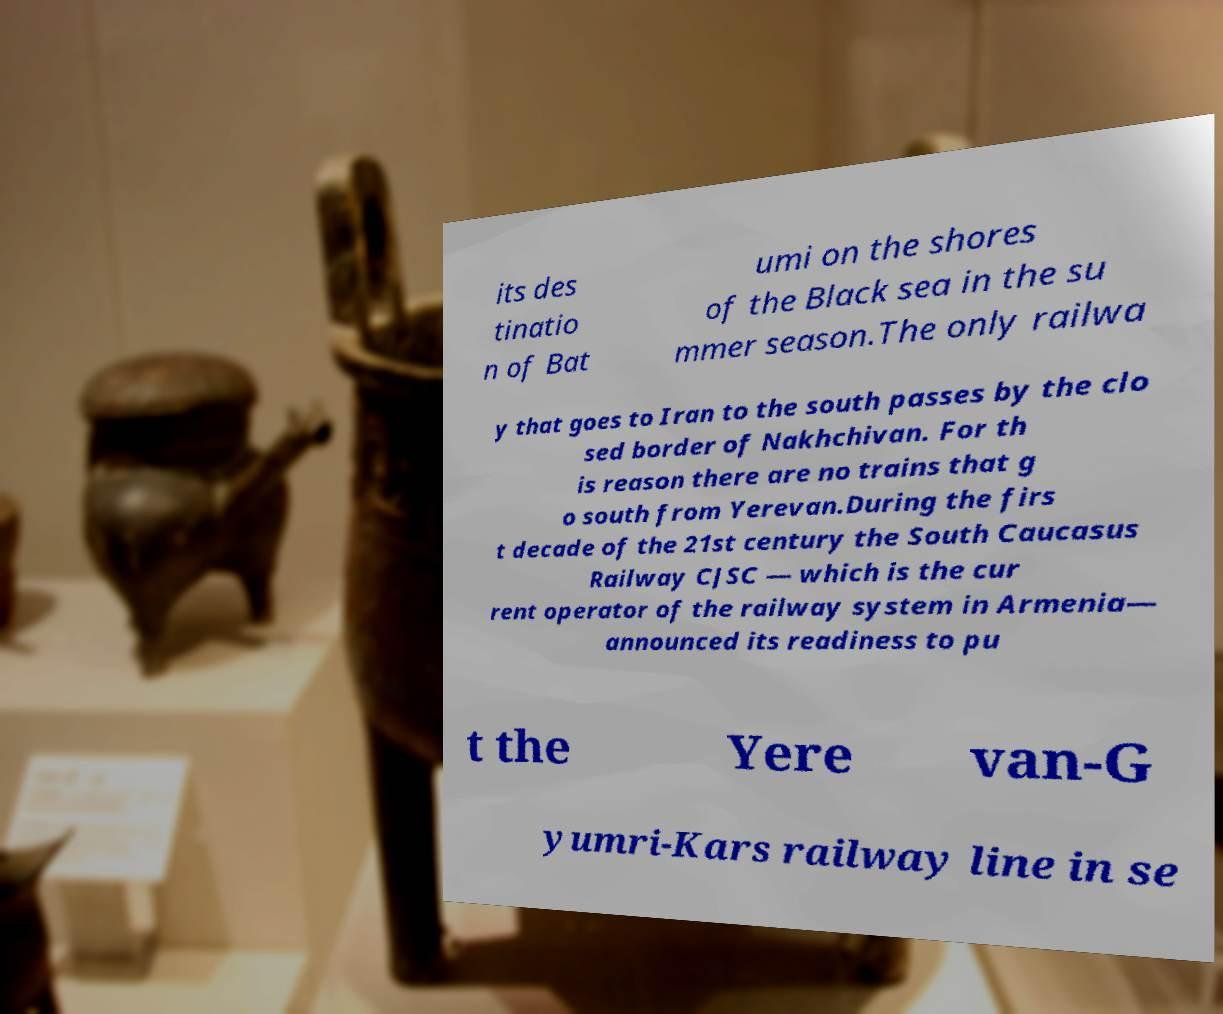What messages or text are displayed in this image? I need them in a readable, typed format. its des tinatio n of Bat umi on the shores of the Black sea in the su mmer season.The only railwa y that goes to Iran to the south passes by the clo sed border of Nakhchivan. For th is reason there are no trains that g o south from Yerevan.During the firs t decade of the 21st century the South Caucasus Railway CJSC — which is the cur rent operator of the railway system in Armenia— announced its readiness to pu t the Yere van-G yumri-Kars railway line in se 